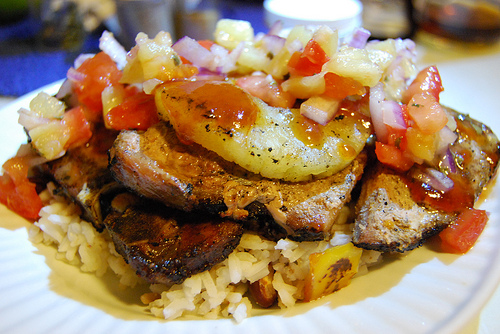<image>
Is there a tomato on the plate? Yes. Looking at the image, I can see the tomato is positioned on top of the plate, with the plate providing support. 